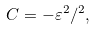Convert formula to latex. <formula><loc_0><loc_0><loc_500><loc_500>C = - \varepsilon ^ { 2 } / { } ^ { 2 } ,</formula> 